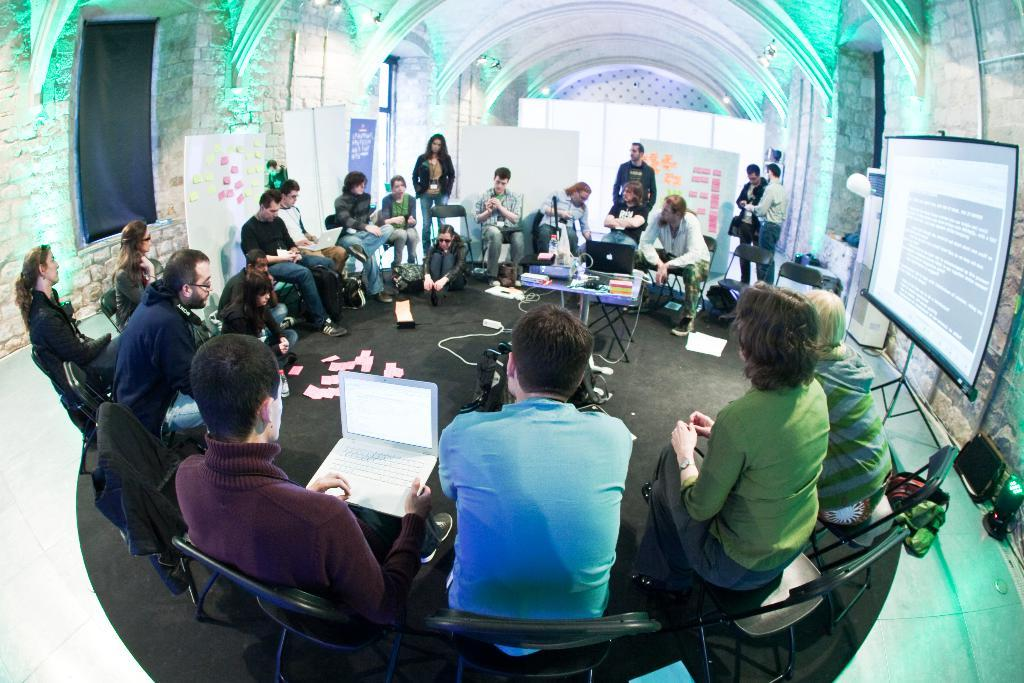How many people are present in the image? There are many people in the image. What are the people doing in the image? The people are sitting on chairs and working. What can be seen on the wall or screen in the image? There is a projector display visible in the image. What type of insect is crawling on the projector display in the image? There is no insect present on the projector display in the image. 